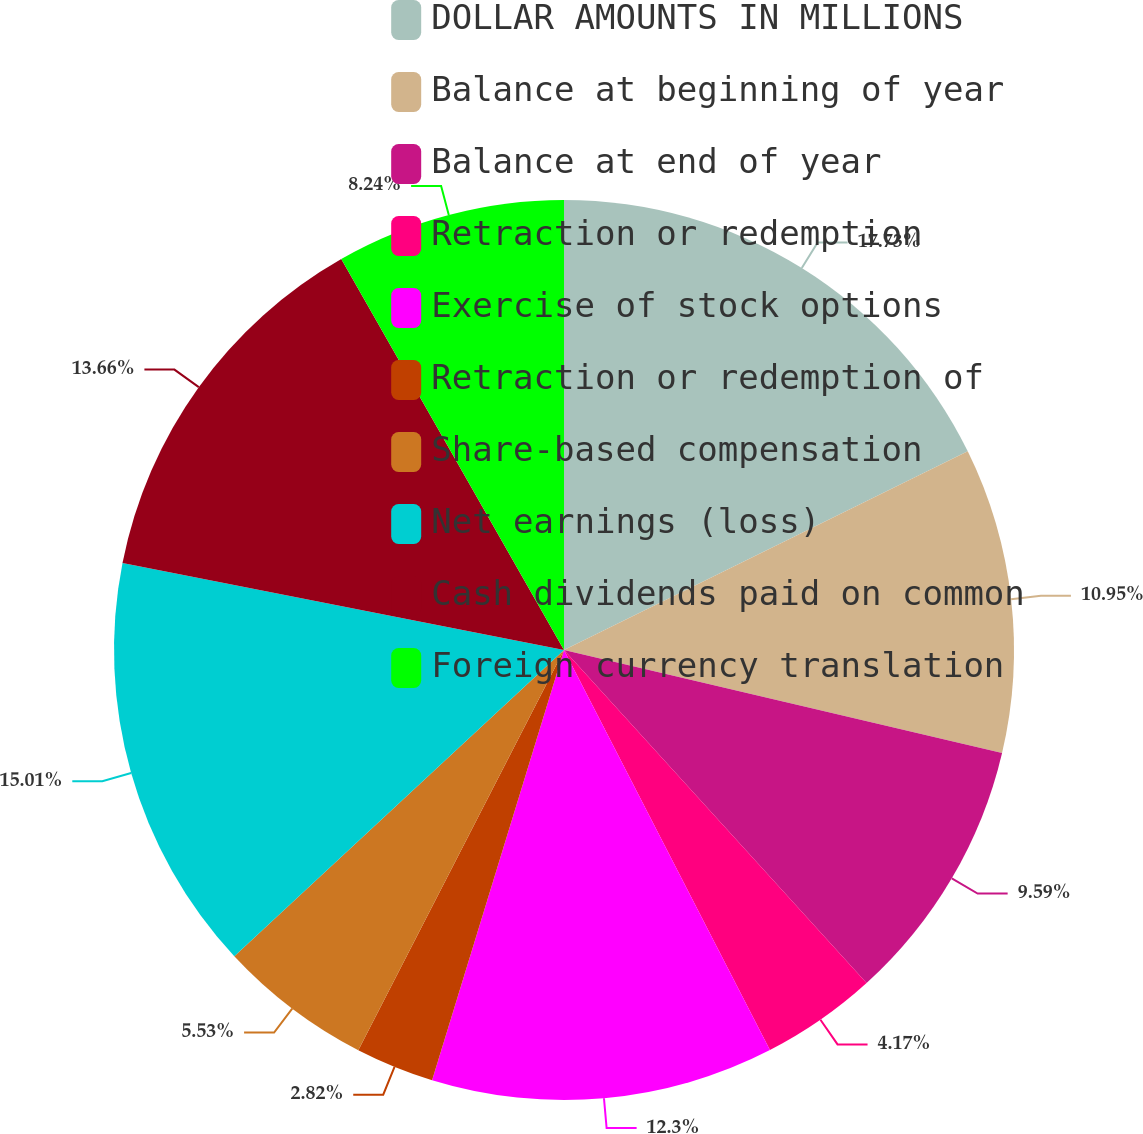Convert chart to OTSL. <chart><loc_0><loc_0><loc_500><loc_500><pie_chart><fcel>DOLLAR AMOUNTS IN MILLIONS<fcel>Balance at beginning of year<fcel>Balance at end of year<fcel>Retraction or redemption<fcel>Exercise of stock options<fcel>Retraction or redemption of<fcel>Share-based compensation<fcel>Net earnings (loss)<fcel>Cash dividends paid on common<fcel>Foreign currency translation<nl><fcel>17.72%<fcel>10.95%<fcel>9.59%<fcel>4.17%<fcel>12.3%<fcel>2.82%<fcel>5.53%<fcel>15.01%<fcel>13.66%<fcel>8.24%<nl></chart> 